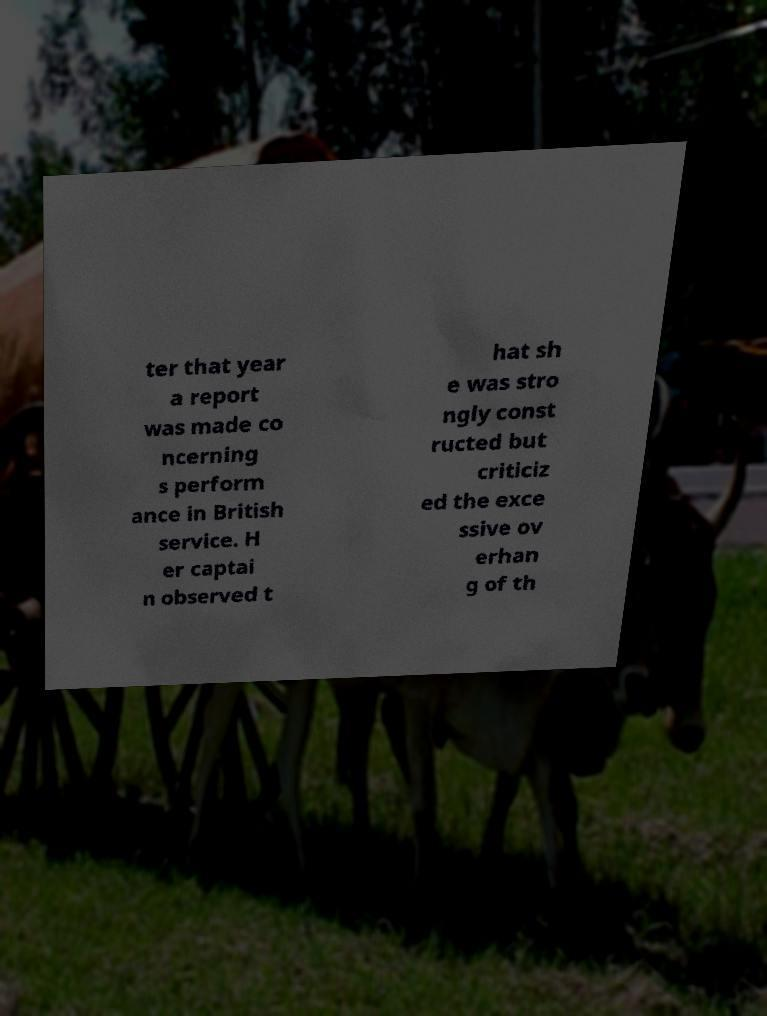There's text embedded in this image that I need extracted. Can you transcribe it verbatim? ter that year a report was made co ncerning s perform ance in British service. H er captai n observed t hat sh e was stro ngly const ructed but criticiz ed the exce ssive ov erhan g of th 